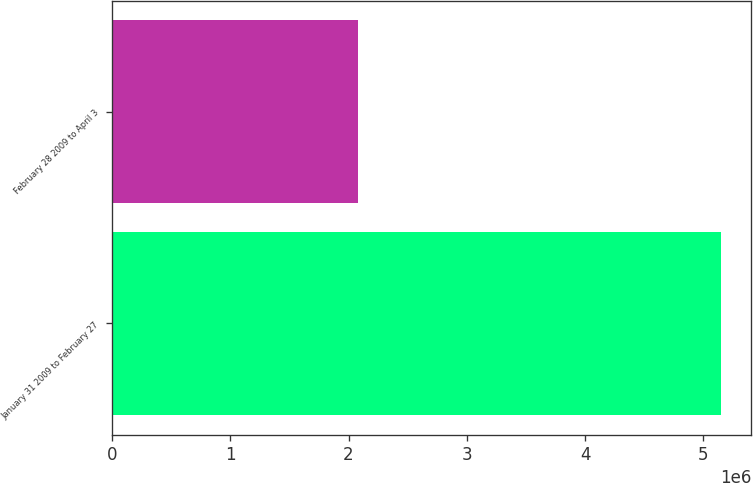<chart> <loc_0><loc_0><loc_500><loc_500><bar_chart><fcel>January 31 2009 to February 27<fcel>February 28 2009 to April 3<nl><fcel>5.1492e+06<fcel>2.0779e+06<nl></chart> 